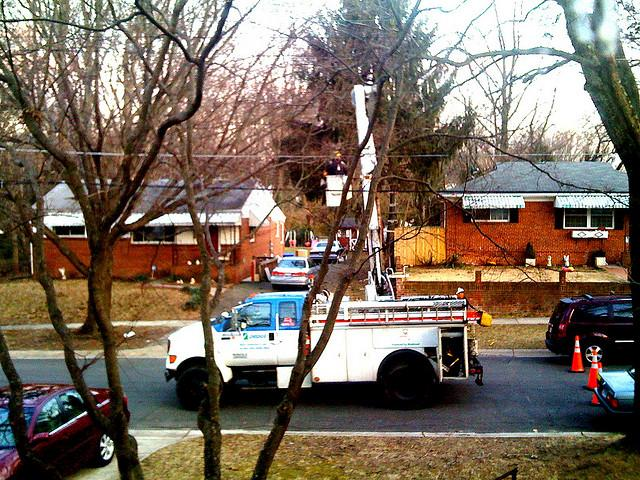Who is the man in the white platform? Please explain your reasoning. utility worker. A man is in a lift connected to a large truck and is working near electrical lines. utility workers work near electric lines. 